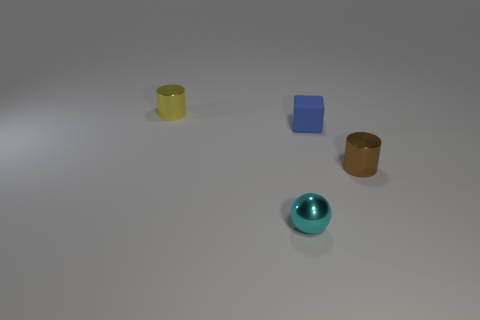Is there any other thing that is made of the same material as the small blue thing?
Keep it short and to the point. No. The matte cube that is the same size as the cyan metallic ball is what color?
Provide a short and direct response. Blue. How many other shiny things are the same shape as the cyan thing?
Keep it short and to the point. 0. How many blocks are either tiny brown objects or small blue things?
Your answer should be very brief. 1. There is a small metal thing that is behind the blue rubber object; does it have the same shape as the thing that is on the right side of the rubber cube?
Ensure brevity in your answer.  Yes. What material is the cube?
Provide a succinct answer. Rubber. What number of gray rubber cylinders are the same size as the brown metal cylinder?
Provide a succinct answer. 0. How many objects are objects in front of the yellow shiny thing or brown metallic cylinders that are in front of the yellow metallic cylinder?
Make the answer very short. 3. Do the small cylinder that is behind the rubber cube and the cylinder to the right of the yellow shiny object have the same material?
Give a very brief answer. Yes. There is a tiny metallic thing in front of the shiny cylinder in front of the tiny blue matte block; what is its shape?
Provide a succinct answer. Sphere. 